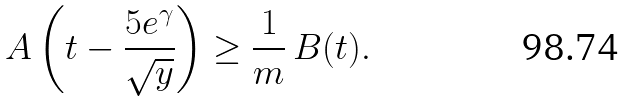Convert formula to latex. <formula><loc_0><loc_0><loc_500><loc_500>A \left ( t - \frac { 5 e ^ { \gamma } } { \sqrt { y } } \right ) \geq \frac { 1 } { m } \, B ( t ) .</formula> 